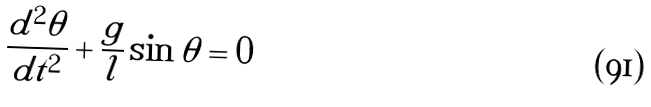<formula> <loc_0><loc_0><loc_500><loc_500>\frac { d ^ { 2 } \theta } { d t ^ { 2 } } + \frac { g } { l } \sin \theta = 0</formula> 